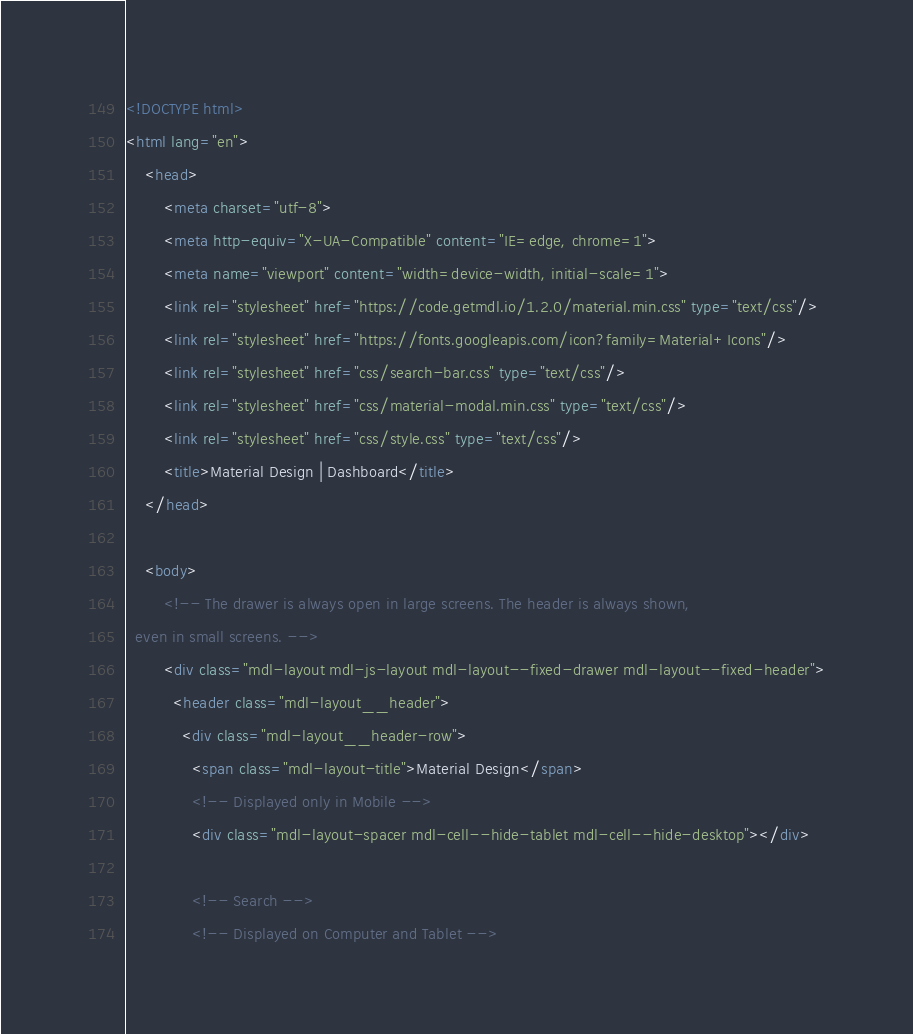<code> <loc_0><loc_0><loc_500><loc_500><_HTML_><!DOCTYPE html>
<html lang="en">
    <head>
        <meta charset="utf-8">
    	<meta http-equiv="X-UA-Compatible" content="IE=edge, chrome=1">
	    <meta name="viewport" content="width=device-width, initial-scale=1">
        <link rel="stylesheet" href="https://code.getmdl.io/1.2.0/material.min.css" type="text/css"/>
        <link rel="stylesheet" href="https://fonts.googleapis.com/icon?family=Material+Icons"/>        
        <link rel="stylesheet" href="css/search-bar.css" type="text/css"/>
        <link rel="stylesheet" href="css/material-modal.min.css" type="text/css"/>
        <link rel="stylesheet" href="css/style.css" type="text/css"/>
        <title>Material Design | Dashboard</title>        
    </head>
    
    <body>
        <!-- The drawer is always open in large screens. The header is always shown,
  even in small screens. -->
        <div class="mdl-layout mdl-js-layout mdl-layout--fixed-drawer mdl-layout--fixed-header">
          <header class="mdl-layout__header">
            <div class="mdl-layout__header-row">
              <span class="mdl-layout-title">Material Design</span>
              <!-- Displayed only in Mobile -->
              <div class="mdl-layout-spacer mdl-cell--hide-tablet mdl-cell--hide-desktop"></div>

              <!-- Search -->
              <!-- Displayed on Computer and Tablet --></code> 